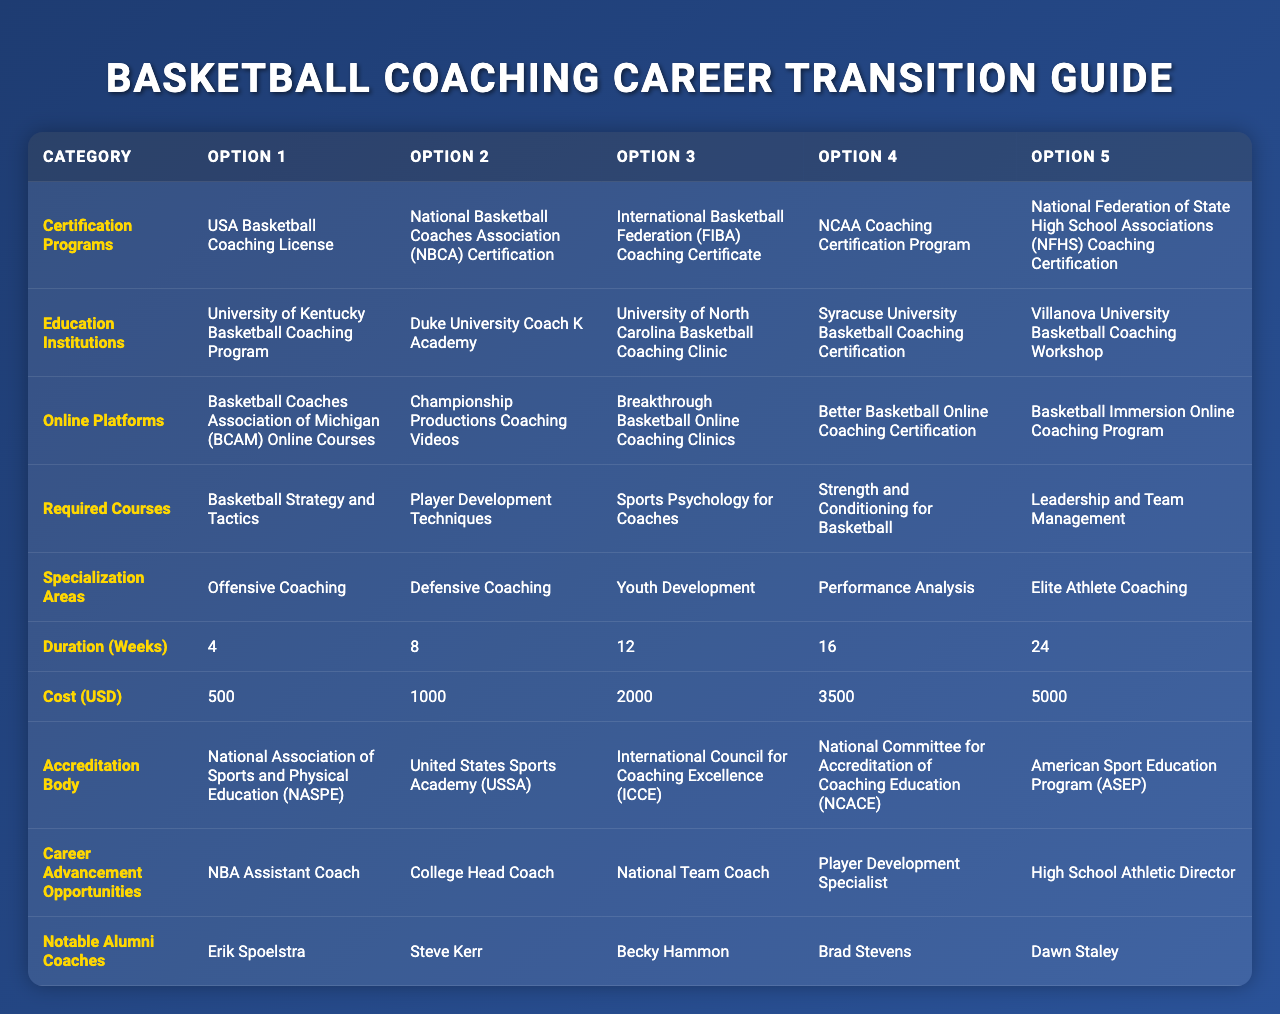What program has the longest duration? The duration of programs listed range from 4 weeks to 24 weeks. The program with the longest duration is the one that is 24 weeks long.
Answer: 24 weeks Which certification requires the highest cost? The costs listed range from $500 to $5000. By identifying the maximum value, the highest cost is $5000.
Answer: $5000 Is the NCAA Coaching Certification Program part of the certification programs? Yes, the NCAA Coaching Certification Program is included in the list of certification programs.
Answer: Yes How many options are available under the specialization areas? There are five specialization areas listed. By counting the items under that category, we confirm there are 5 options.
Answer: 5 What is the average cost of the certification programs listed? The costs listed are $500, $1000, $2000, $3500, and $5000. To calculate the average, sum them: 500 + 1000 + 2000 + 3500 + 5000 = 13000, then divide by 5, which results in 13000 / 5 = 2600.
Answer: $2600 Which accreditation body is associated with the NFHS Coaching Certification? The NFHS Coaching Certification is associated with the National Association of Sports and Physical Education (NASPE), as it is listed as the first accreditation body.
Answer: National Association of Sports and Physical Education (NASPE) What is the total number of notable alumni coaches mentioned? There are five notable alumni coaches listed. Thus, the total count is simply five.
Answer: 5 Is there a coaching certification program that lasts fewer than 8 weeks? Yes, there is a coaching program listed that lasts for 4 weeks, which is fewer than 8 weeks.
Answer: Yes What is the difference in duration between the shortest and longest certification programs? The shortest program lasts 4 weeks, and the longest lasts 24 weeks. The difference is 24 - 4 = 20 weeks.
Answer: 20 weeks Which coaching certification program costs $2000? The program that costs $2000 is the National Basketball Coaches Association (NBCA) Certification, as per the cost billing provided.
Answer: National Basketball Coaches Association (NBCA) Certification 